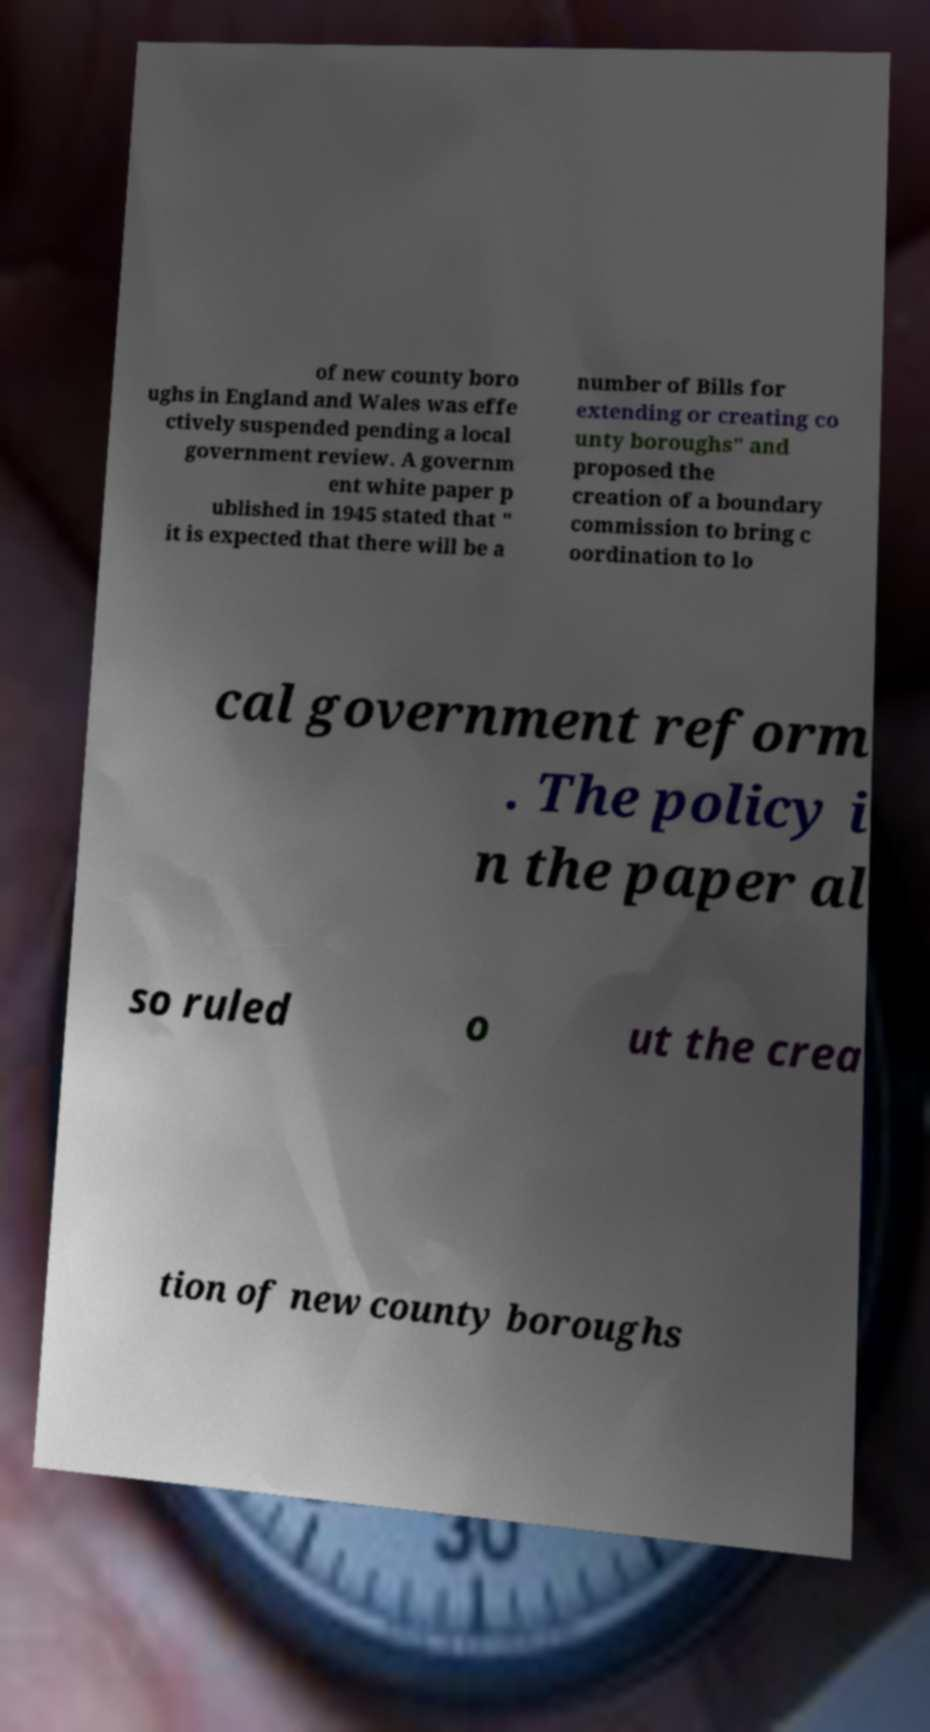Please identify and transcribe the text found in this image. of new county boro ughs in England and Wales was effe ctively suspended pending a local government review. A governm ent white paper p ublished in 1945 stated that " it is expected that there will be a number of Bills for extending or creating co unty boroughs" and proposed the creation of a boundary commission to bring c oordination to lo cal government reform . The policy i n the paper al so ruled o ut the crea tion of new county boroughs 